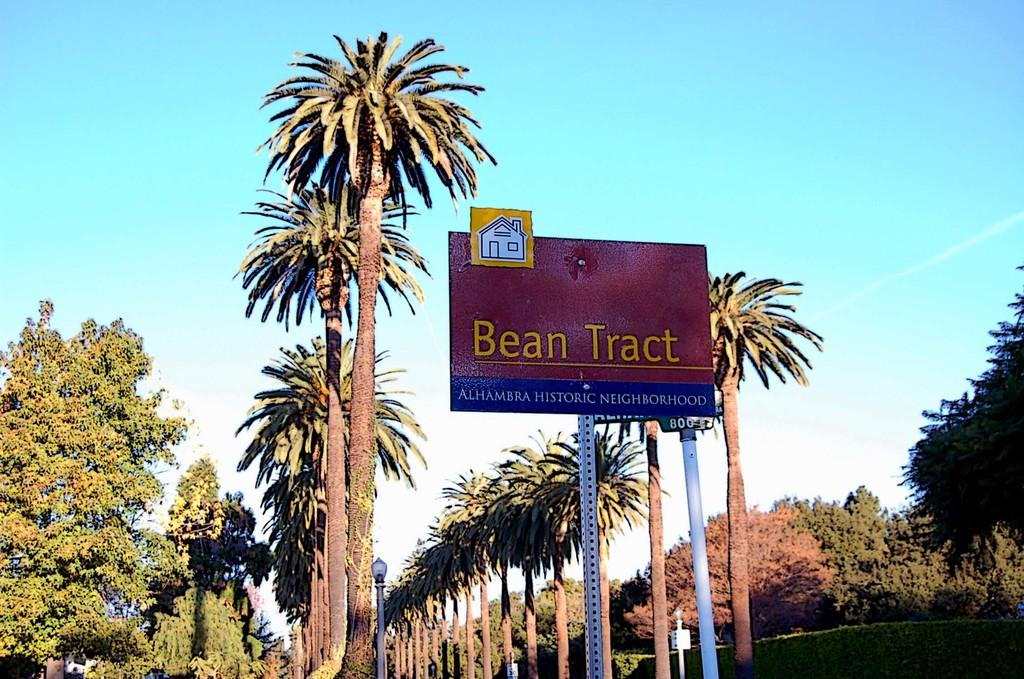What type of natural elements can be seen in the image? There are trees in the image. What is written on the board with text in the image? The provided facts do not mention the content of the text on the board. What can be used for illumination in the image? There are lights visible in the image. How would you describe the sky in the image? The sky is blue and cloudy in the image. Where is the desk located in the image? There is no desk present in the image. What type of trip can be seen in the image? There is no trip visible in the image. 